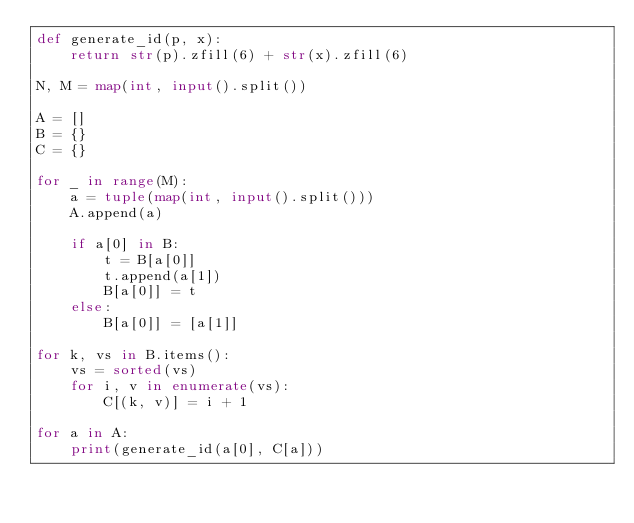Convert code to text. <code><loc_0><loc_0><loc_500><loc_500><_Python_>def generate_id(p, x):
    return str(p).zfill(6) + str(x).zfill(6)

N, M = map(int, input().split())

A = []
B = {}
C = {}

for _ in range(M):
    a = tuple(map(int, input().split()))
    A.append(a)

    if a[0] in B:
        t = B[a[0]]
        t.append(a[1])
        B[a[0]] = t
    else:
        B[a[0]] = [a[1]]

for k, vs in B.items():
    vs = sorted(vs)
    for i, v in enumerate(vs):
        C[(k, v)] = i + 1

for a in A:
    print(generate_id(a[0], C[a]))
</code> 